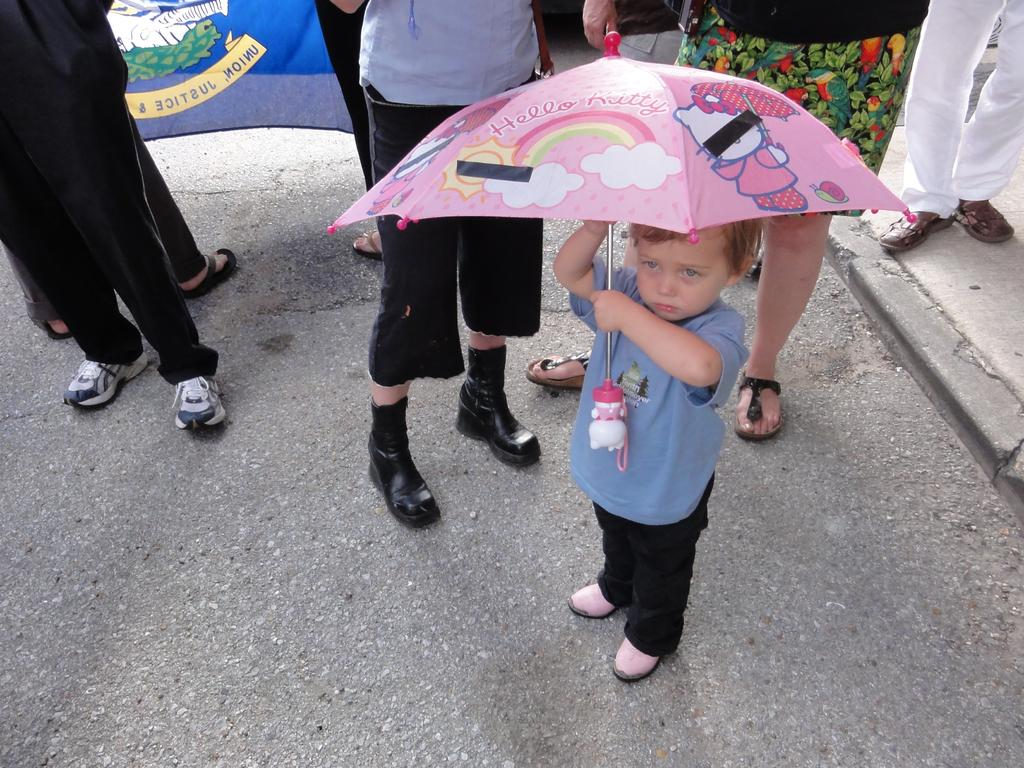Who is the main subject in the image? There is a boy in the image. What is the boy doing in the image? The boy is standing in the image. What object is the boy holding in the image? The boy is holding a pink color umbrella in the image. What can be seen in the background of the image? There is a group of people in the background of the image. What is at the bottom of the image? There is a road at the bottom of the image. What is the name of the dust storm in the image? There is no dust storm present in the image. Who is leading the group of people in the background of the image? The image does not provide information about who is leading the group of people in the background. 